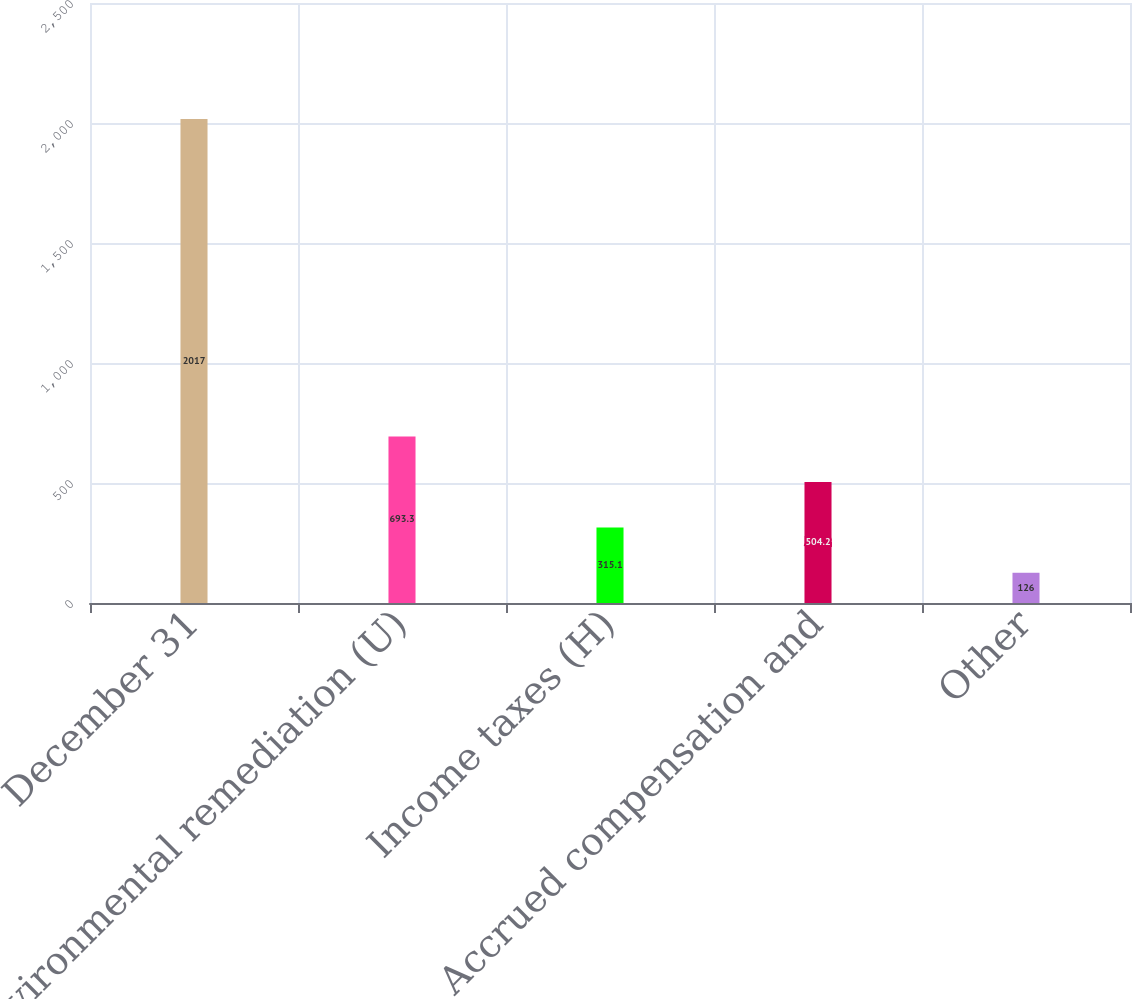Convert chart. <chart><loc_0><loc_0><loc_500><loc_500><bar_chart><fcel>December 31<fcel>Environmental remediation (U)<fcel>Income taxes (H)<fcel>Accrued compensation and<fcel>Other<nl><fcel>2017<fcel>693.3<fcel>315.1<fcel>504.2<fcel>126<nl></chart> 